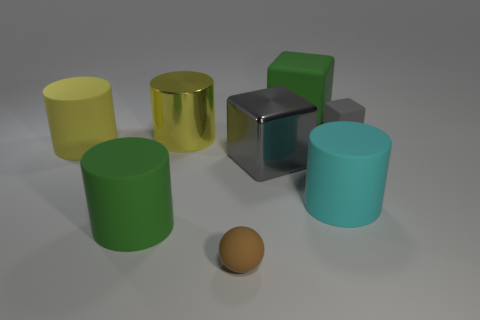Is the material of the cyan thing the same as the tiny gray block?
Provide a short and direct response. Yes. How many brown things have the same shape as the big cyan rubber thing?
Keep it short and to the point. 0. There is a gray thing that is made of the same material as the cyan cylinder; what is its shape?
Provide a short and direct response. Cube. What color is the large cylinder on the left side of the green thing on the left side of the gray metal block?
Keep it short and to the point. Yellow. Is the metal cylinder the same color as the small rubber sphere?
Keep it short and to the point. No. There is a gray block that is on the left side of the rubber block that is behind the small gray block; what is its material?
Offer a terse response. Metal. There is another gray object that is the same shape as the gray metallic object; what is it made of?
Offer a terse response. Rubber. Are there any big cyan rubber cylinders on the left side of the big cylinder on the right side of the big green matte object that is behind the big gray object?
Make the answer very short. No. How many other objects are the same color as the tiny ball?
Provide a short and direct response. 0. What number of rubber objects are both on the left side of the cyan object and behind the big cyan object?
Ensure brevity in your answer.  2. 